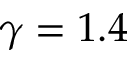<formula> <loc_0><loc_0><loc_500><loc_500>\gamma = 1 . 4</formula> 